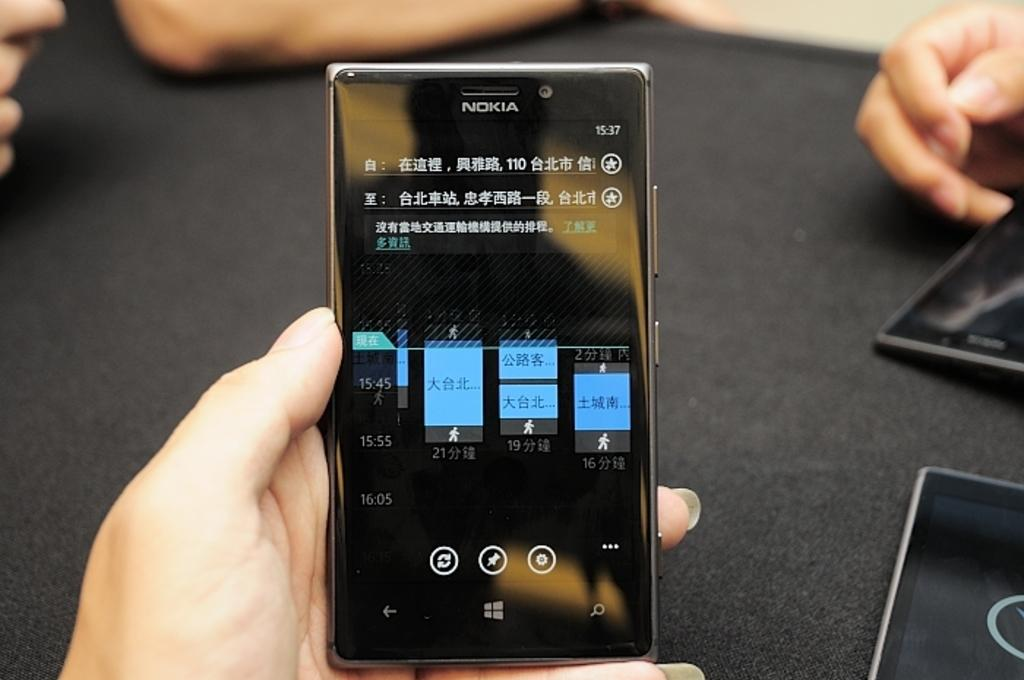<image>
Write a terse but informative summary of the picture. Person holding a black phone that says NOKIA on it. 